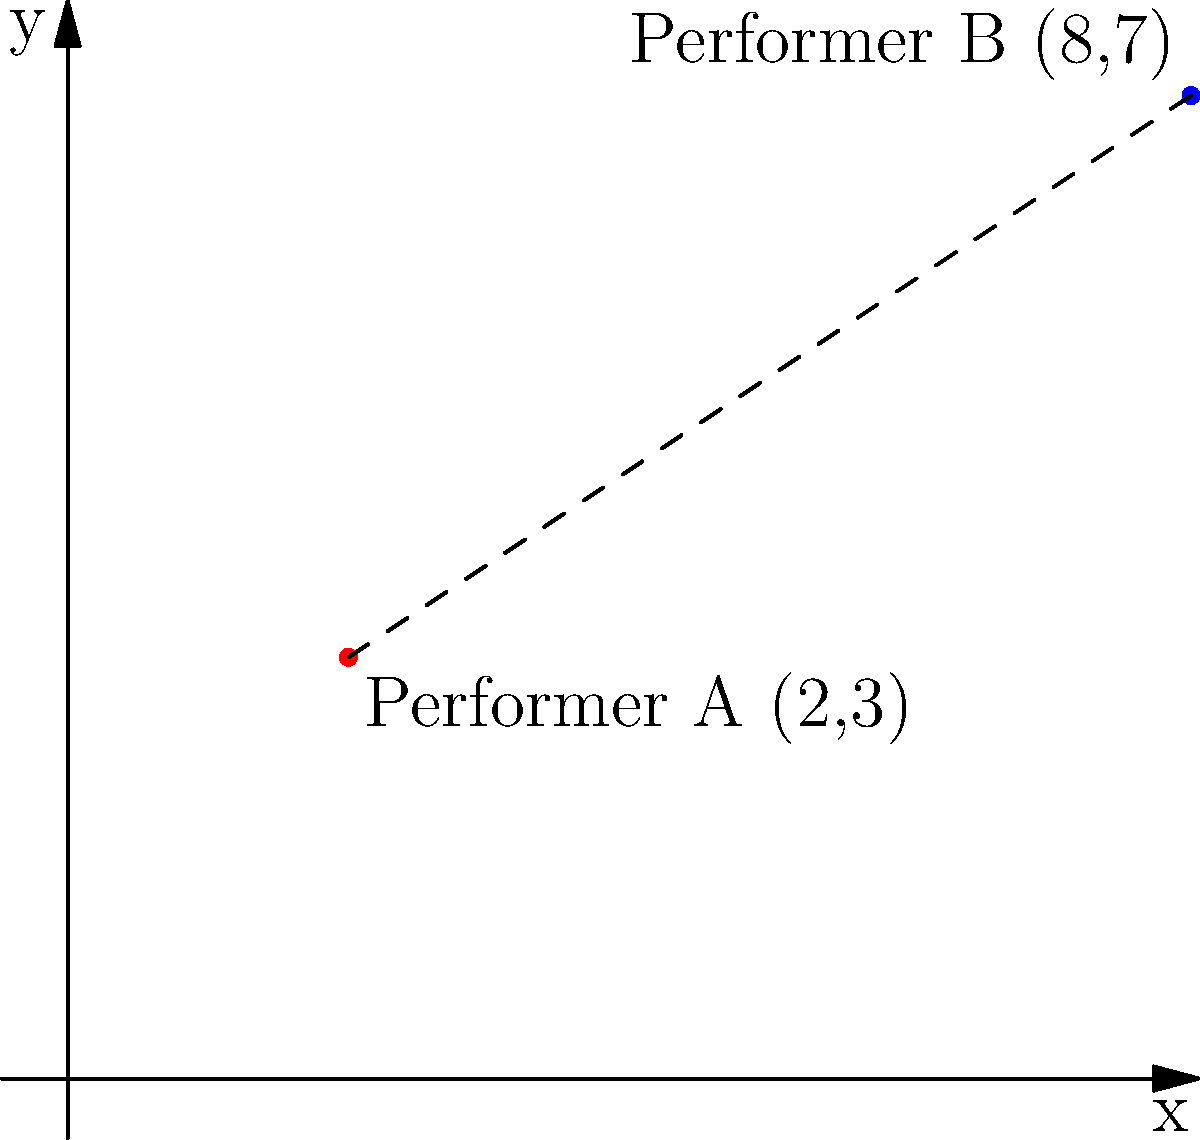During a performance on the cruise ship's deck, two performers need to calculate their distance from each other. Performer A is standing at coordinates (2,3) and Performer B is at (8,7). Using the distance formula, calculate the distance between the two performers to the nearest tenth of a unit. To solve this problem, we'll use the distance formula:

$$d = \sqrt{(x_2-x_1)^2 + (y_2-y_1)^2}$$

Where $(x_1,y_1)$ is the position of Performer A and $(x_2,y_2)$ is the position of Performer B.

Step 1: Identify the coordinates
Performer A: $(x_1,y_1) = (2,3)$
Performer B: $(x_2,y_2) = (8,7)$

Step 2: Plug the coordinates into the distance formula
$$d = \sqrt{(8-2)^2 + (7-3)^2}$$

Step 3: Simplify the expressions inside the parentheses
$$d = \sqrt{6^2 + 4^2}$$

Step 4: Calculate the squares
$$d = \sqrt{36 + 16}$$

Step 5: Add the numbers under the square root
$$d = \sqrt{52}$$

Step 6: Calculate the square root and round to the nearest tenth
$$d \approx 7.2$$

Therefore, the distance between the two performers is approximately 7.2 units.
Answer: 7.2 units 